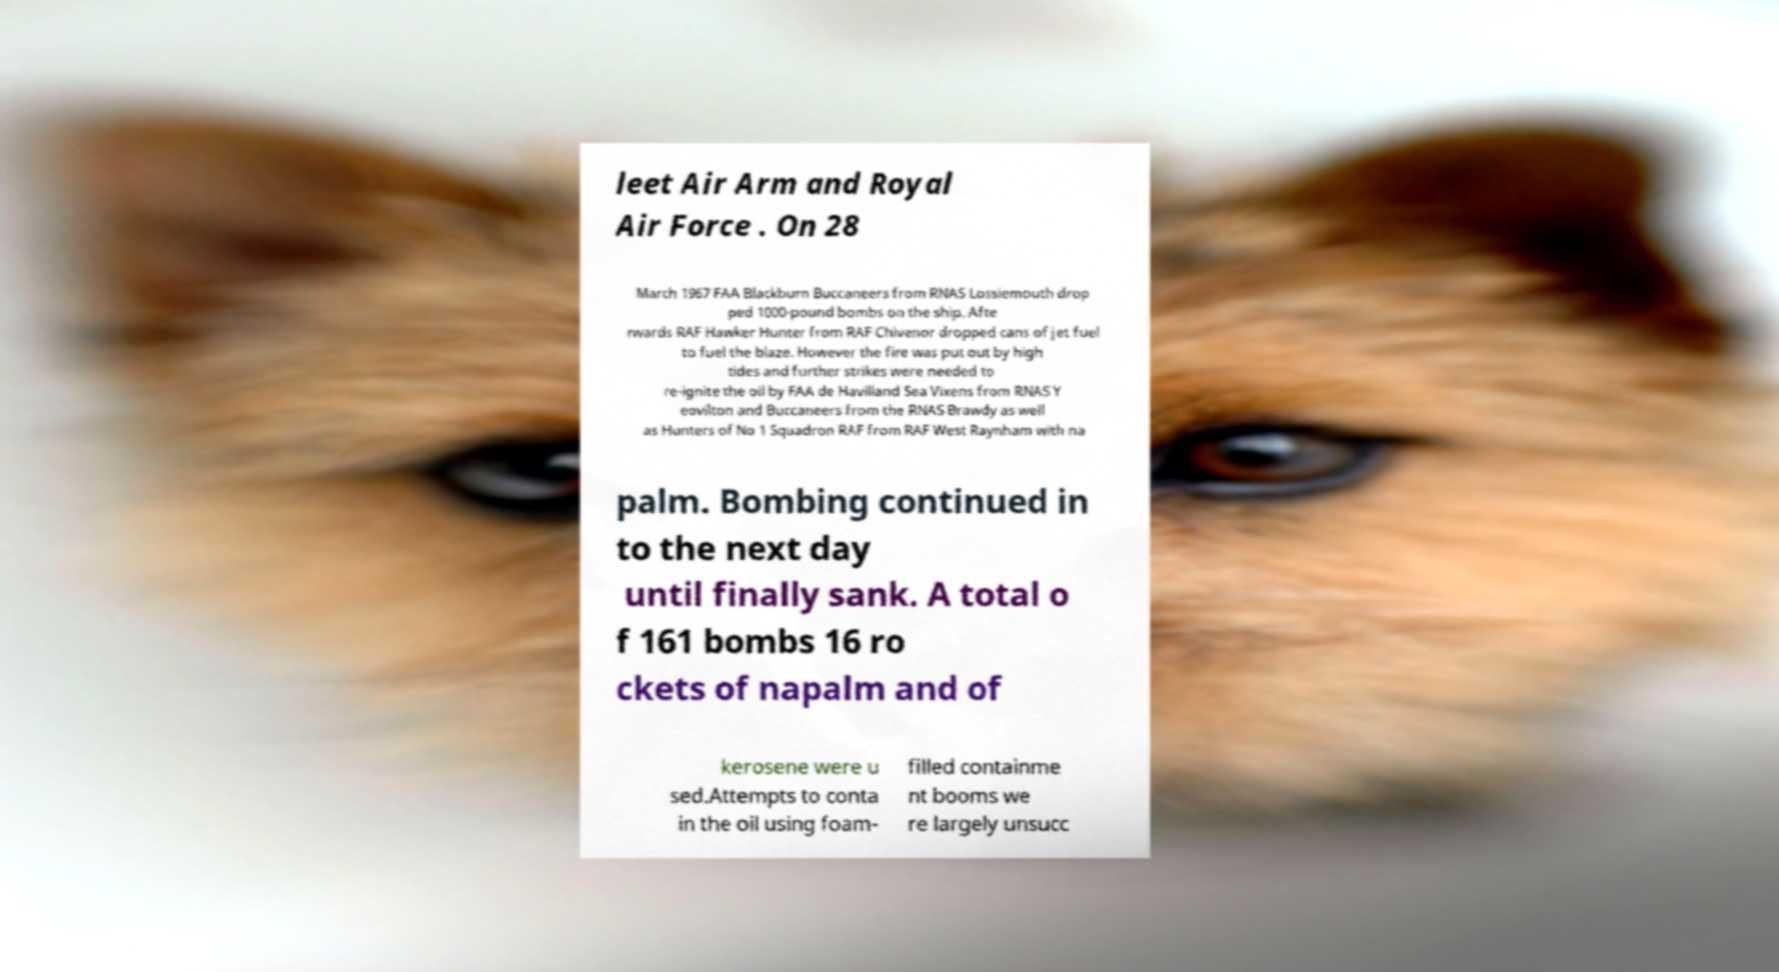What messages or text are displayed in this image? I need them in a readable, typed format. leet Air Arm and Royal Air Force . On 28 March 1967 FAA Blackburn Buccaneers from RNAS Lossiemouth drop ped 1000-pound bombs on the ship. Afte rwards RAF Hawker Hunter from RAF Chivenor dropped cans of jet fuel to fuel the blaze. However the fire was put out by high tides and further strikes were needed to re-ignite the oil by FAA de Havilland Sea Vixens from RNAS Y eovilton and Buccaneers from the RNAS Brawdy as well as Hunters of No 1 Squadron RAF from RAF West Raynham with na palm. Bombing continued in to the next day until finally sank. A total o f 161 bombs 16 ro ckets of napalm and of kerosene were u sed.Attempts to conta in the oil using foam- filled containme nt booms we re largely unsucc 